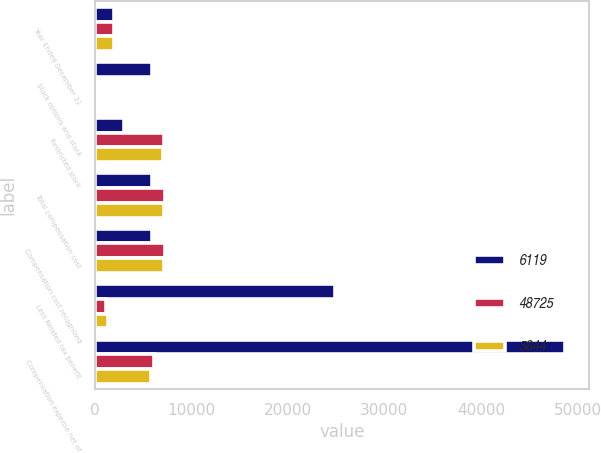Convert chart. <chart><loc_0><loc_0><loc_500><loc_500><stacked_bar_chart><ecel><fcel>Year Ended December 31<fcel>Stock options and stock<fcel>Restricted stock<fcel>Total compensation cost<fcel>Compensation cost recognized<fcel>Less Related tax benefit<fcel>Compensation expense net of<nl><fcel>6119<fcel>2006<fcel>5981.5<fcel>3038<fcel>5981.5<fcel>5981.5<fcel>24901<fcel>48725<nl><fcel>48725<fcel>2005<fcel>139<fcel>7184<fcel>7323<fcel>7323<fcel>1204<fcel>6119<nl><fcel>5844<fcel>2004<fcel>78<fcel>7092<fcel>7170<fcel>7170<fcel>1326<fcel>5844<nl></chart> 